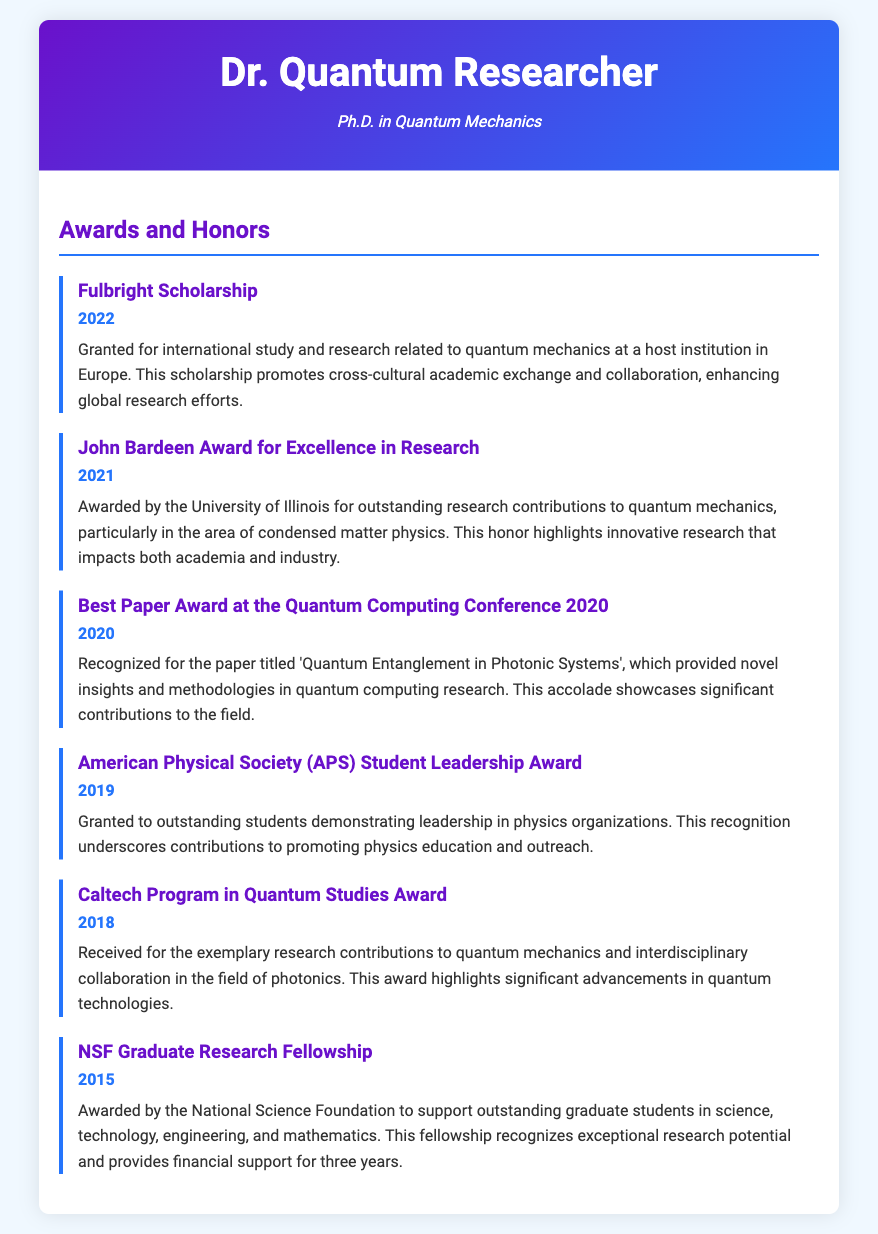What is the first award listed? The first award mentioned in the document is the Fulbright Scholarship.
Answer: Fulbright Scholarship In what year did the recipient receive the John Bardeen Award for Excellence in Research? The John Bardeen Award for Excellence in Research was received in 2021.
Answer: 2021 What event recognized the paper on Quantum Entanglement? The Best Paper Award at the Quantum Computing Conference recognized the paper.
Answer: Quantum Computing Conference Which award highlights contributions to physics education and outreach? The American Physical Society (APS) Student Leadership Award highlights contributions to education and outreach.
Answer: APS Student Leadership Award How many years of financial support does the NSF Graduate Research Fellowship provide? The NSF Graduate Research Fellowship provides financial support for three years.
Answer: three years What is the significance of the Fulbright Scholarship mentioned? It promotes cross-cultural academic exchange and collaboration in quantum mechanics research.
Answer: cross-cultural academic exchange Which award specifically recognizes innovative research in condensed matter physics? The John Bardeen Award for Excellence in Research specifically recognizes innovative research in this area.
Answer: John Bardeen Award What year was the Caltech Program in Quantum Studies Award received? The Caltech Program in Quantum Studies Award was received in 2018.
Answer: 2018 